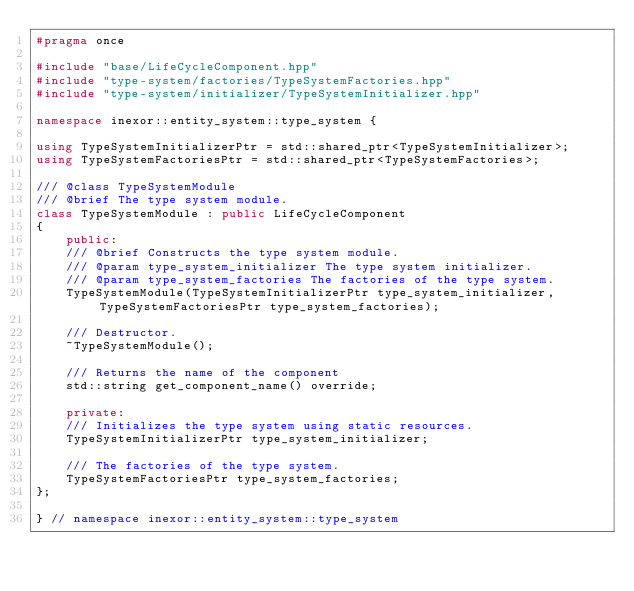Convert code to text. <code><loc_0><loc_0><loc_500><loc_500><_C++_>#pragma once

#include "base/LifeCycleComponent.hpp"
#include "type-system/factories/TypeSystemFactories.hpp"
#include "type-system/initializer/TypeSystemInitializer.hpp"

namespace inexor::entity_system::type_system {

using TypeSystemInitializerPtr = std::shared_ptr<TypeSystemInitializer>;
using TypeSystemFactoriesPtr = std::shared_ptr<TypeSystemFactories>;

/// @class TypeSystemModule
/// @brief The type system module.
class TypeSystemModule : public LifeCycleComponent
{
    public:
    /// @brief Constructs the type system module.
    /// @param type_system_initializer The type system initializer.
    /// @param type_system_factories The factories of the type system.
    TypeSystemModule(TypeSystemInitializerPtr type_system_initializer, TypeSystemFactoriesPtr type_system_factories);

    /// Destructor.
    ~TypeSystemModule();

    /// Returns the name of the component
    std::string get_component_name() override;

    private:
    /// Initializes the type system using static resources.
    TypeSystemInitializerPtr type_system_initializer;

    /// The factories of the type system.
    TypeSystemFactoriesPtr type_system_factories;
};

} // namespace inexor::entity_system::type_system
</code> 